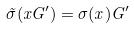<formula> <loc_0><loc_0><loc_500><loc_500>\tilde { \sigma } ( x G ^ { \prime } ) = \sigma ( x ) G ^ { \prime }</formula> 